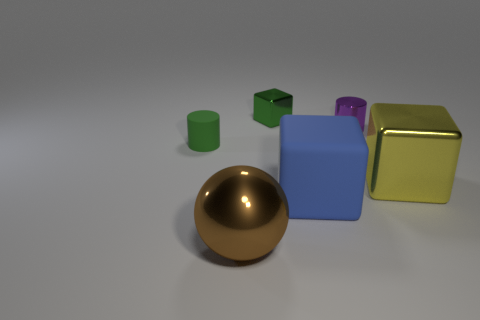Add 1 big yellow shiny things. How many objects exist? 7 Subtract all cylinders. How many objects are left? 4 Add 6 big purple shiny objects. How many big purple shiny objects exist? 6 Subtract 1 green blocks. How many objects are left? 5 Subtract all small cyan matte cubes. Subtract all large blue matte blocks. How many objects are left? 5 Add 3 tiny metal blocks. How many tiny metal blocks are left? 4 